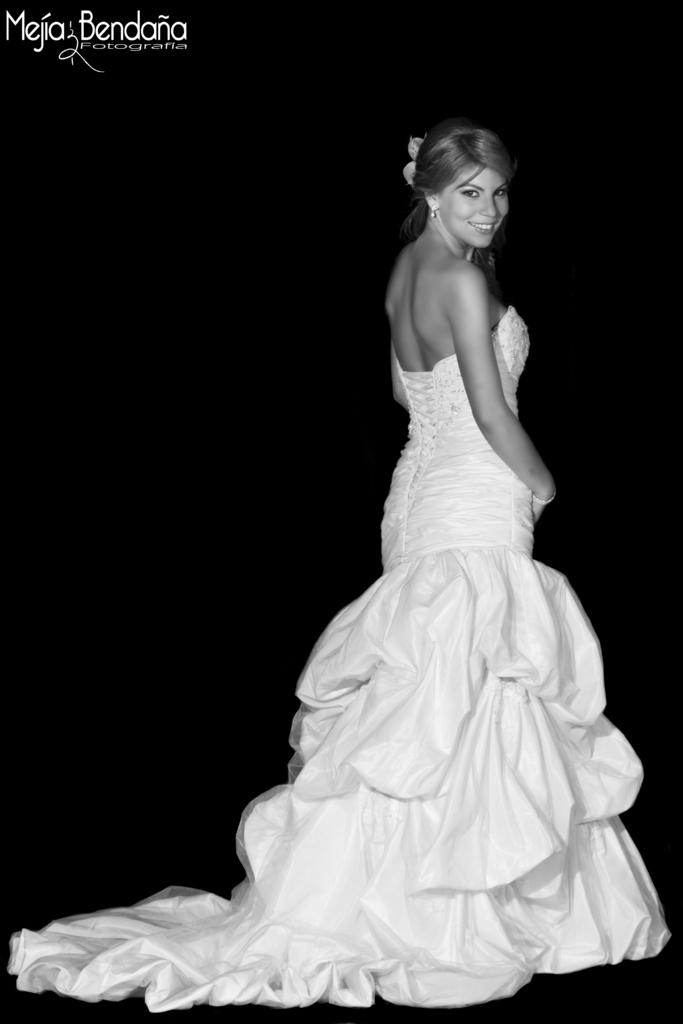Who is the main subject in the image? There is a woman in the image. What is the woman wearing? The woman is wearing a wedding dress. What type of coat is the woman wearing in the image? The woman is not wearing a coat in the image; she is wearing a wedding dress. How many plates can be seen on the table in the image? There is no table or plates present in the image; it only features a woman wearing a wedding dress. 